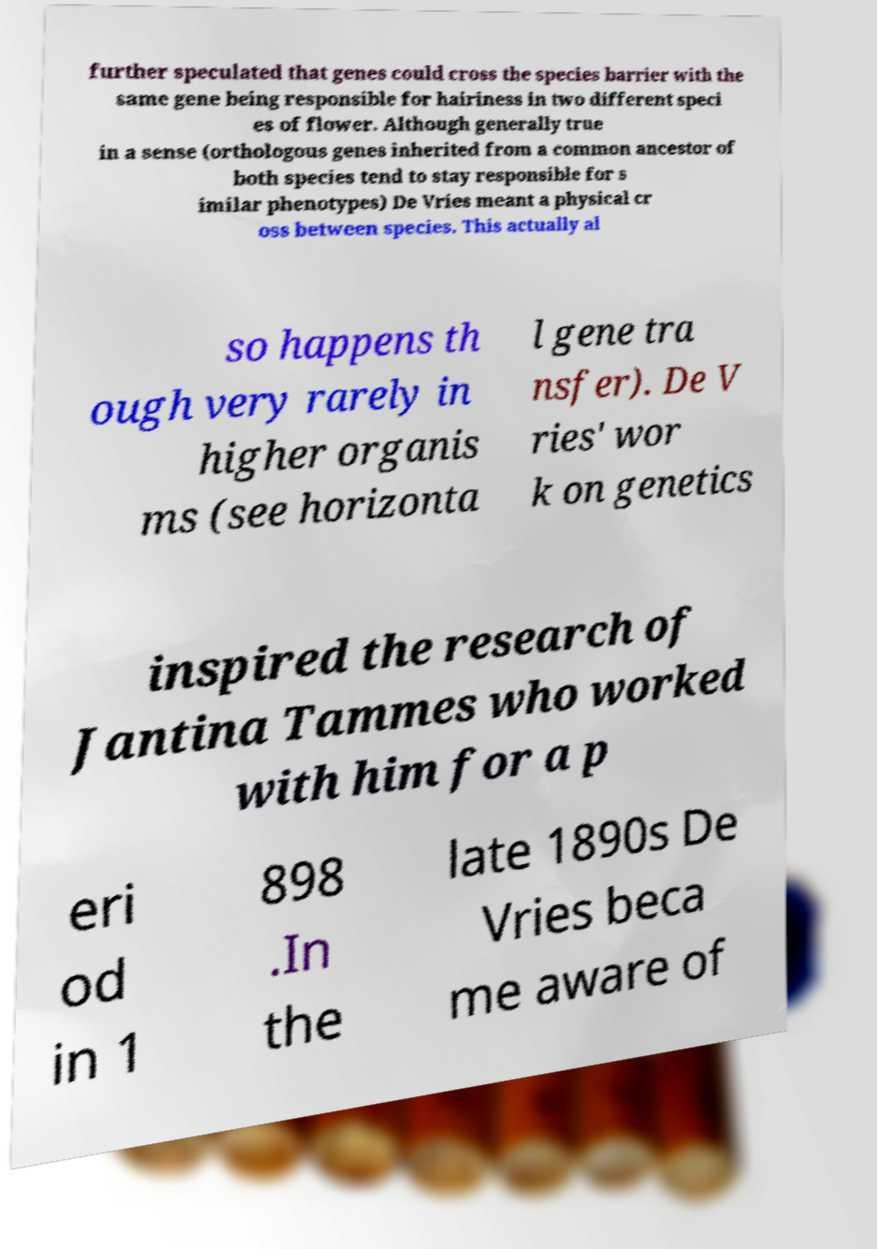Could you extract and type out the text from this image? further speculated that genes could cross the species barrier with the same gene being responsible for hairiness in two different speci es of flower. Although generally true in a sense (orthologous genes inherited from a common ancestor of both species tend to stay responsible for s imilar phenotypes) De Vries meant a physical cr oss between species. This actually al so happens th ough very rarely in higher organis ms (see horizonta l gene tra nsfer). De V ries' wor k on genetics inspired the research of Jantina Tammes who worked with him for a p eri od in 1 898 .In the late 1890s De Vries beca me aware of 